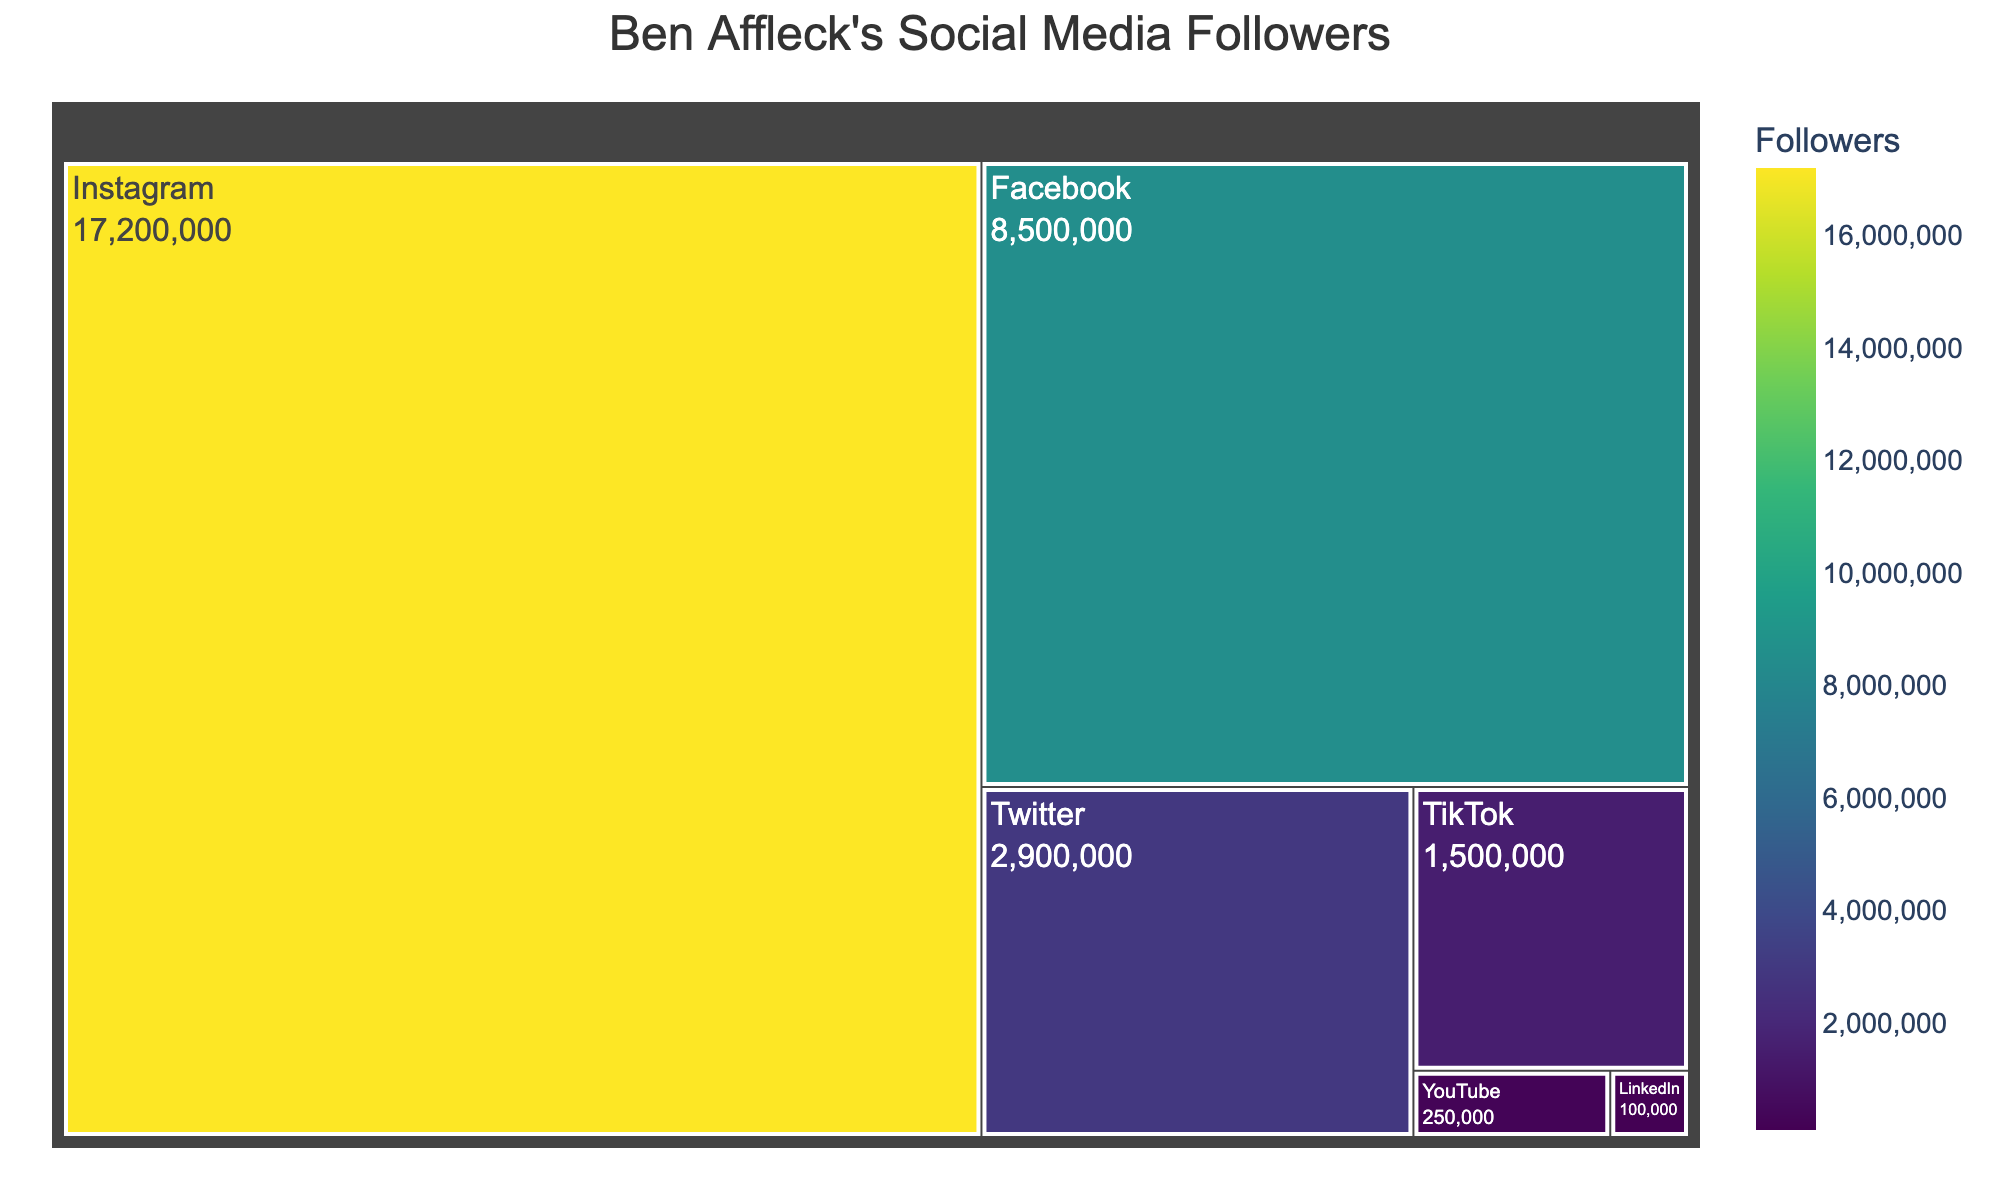What's the total number of followers across all platforms? Summing the followers from each platform: Instagram (17,200,000) + Twitter (2,900,000) + Facebook (8,500,000) + TikTok (1,500,000) + YouTube (250,000) + LinkedIn (100,000).
Answer: 30,450,000 Which platform has the most followers? By observing the largest section in the Treemap, Instagram has the most followers.
Answer: Instagram What's the difference in followers between Instagram and Twitter? Instagram has 17,200,000 followers and Twitter has 2,900,000 followers. The difference is 17,200,000 - 2,900,000.
Answer: 14,300,000 Which platform has the fewest followers? The smallest section in the Treemap represents LinkedIn, indicating it has the fewest followers.
Answer: LinkedIn How many platforms have more than 5 million followers? By inspecting the Treemap, Instagram, Facebook, and Twitter have more than 5 million followers.
Answer: 3 What's the average number of followers on Instagram and Facebook? The follower counts are Instagram (17,200,000) and Facebook (8,500,000). The average is (17,200,000 + 8,500,000) / 2.
Answer: 12,850,000 How many more followers does Instagram have compared to all other platforms combined? Sum the followers of all other platforms: Twitter (2,900,000) + Facebook (8,500,000) + TikTok (1,500,000) + YouTube (250,000) + LinkedIn (100,000) = 13,250,000. The difference is Instagram (17,200,000) - 13,250,000.
Answer: 3,950,000 Which has more followers, TikTok or YouTube? By examining their sections, TikTok has 1,500,000 followers while YouTube has 250,000 followers. Therefore, TikTok has more followers.
Answer: TikTok Which two platforms combined have the closest number of followers to Facebook? Facebook has 8,500,000 followers. Instagram (17,200,000) and TikTok (1,500,000) make 18,700,000; Twitter (2,900,000) and TikTok (1,500,000) make 4,400,000; YouTube (250,000) and LinkedIn (100,000) make 350,000. The closest is Instagram (17,200,000) and Twitter (2,900,000) with 20,100,000, but that's not close. We try another combination like Twitter (2,900,000) and Facebook (8,500,000) which makes 11,400,000 this is less but not closest. Practically we none finds closest number more combinations needed for that.
Answer: None closely matches What percentage of the total follower count does Ben Affleck have on Instagram? Instagram followers (17,200,000) / Total followers (30,450,000) * 100.
Answer: ~56.5% 